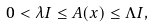<formula> <loc_0><loc_0><loc_500><loc_500>0 < \lambda I \leq A ( x ) \leq \Lambda I ,</formula> 